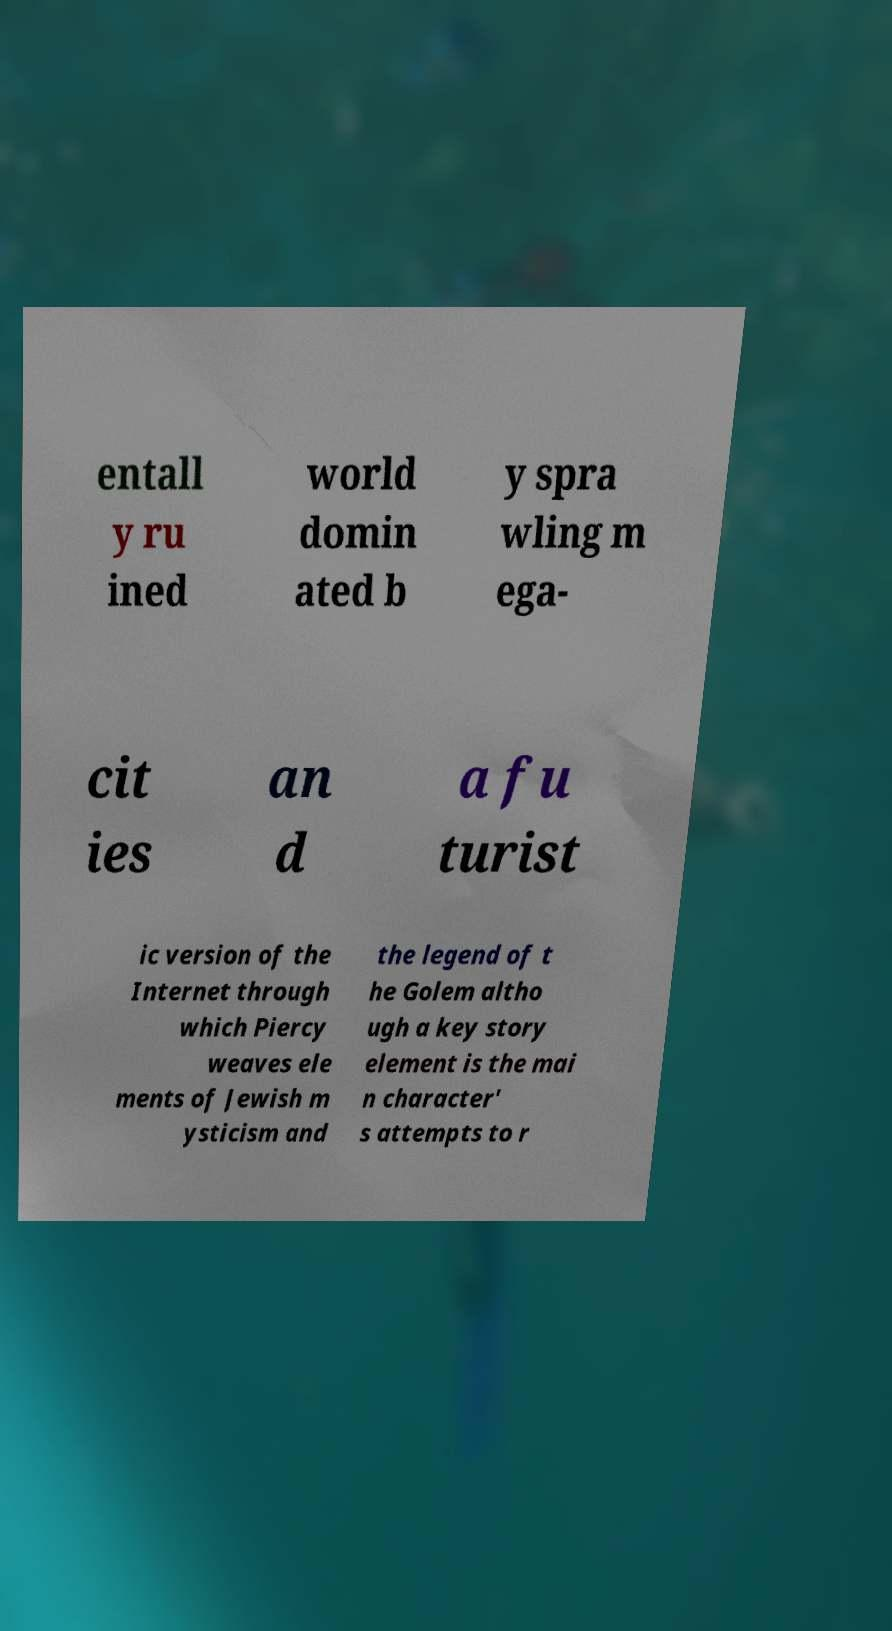I need the written content from this picture converted into text. Can you do that? entall y ru ined world domin ated b y spra wling m ega- cit ies an d a fu turist ic version of the Internet through which Piercy weaves ele ments of Jewish m ysticism and the legend of t he Golem altho ugh a key story element is the mai n character' s attempts to r 